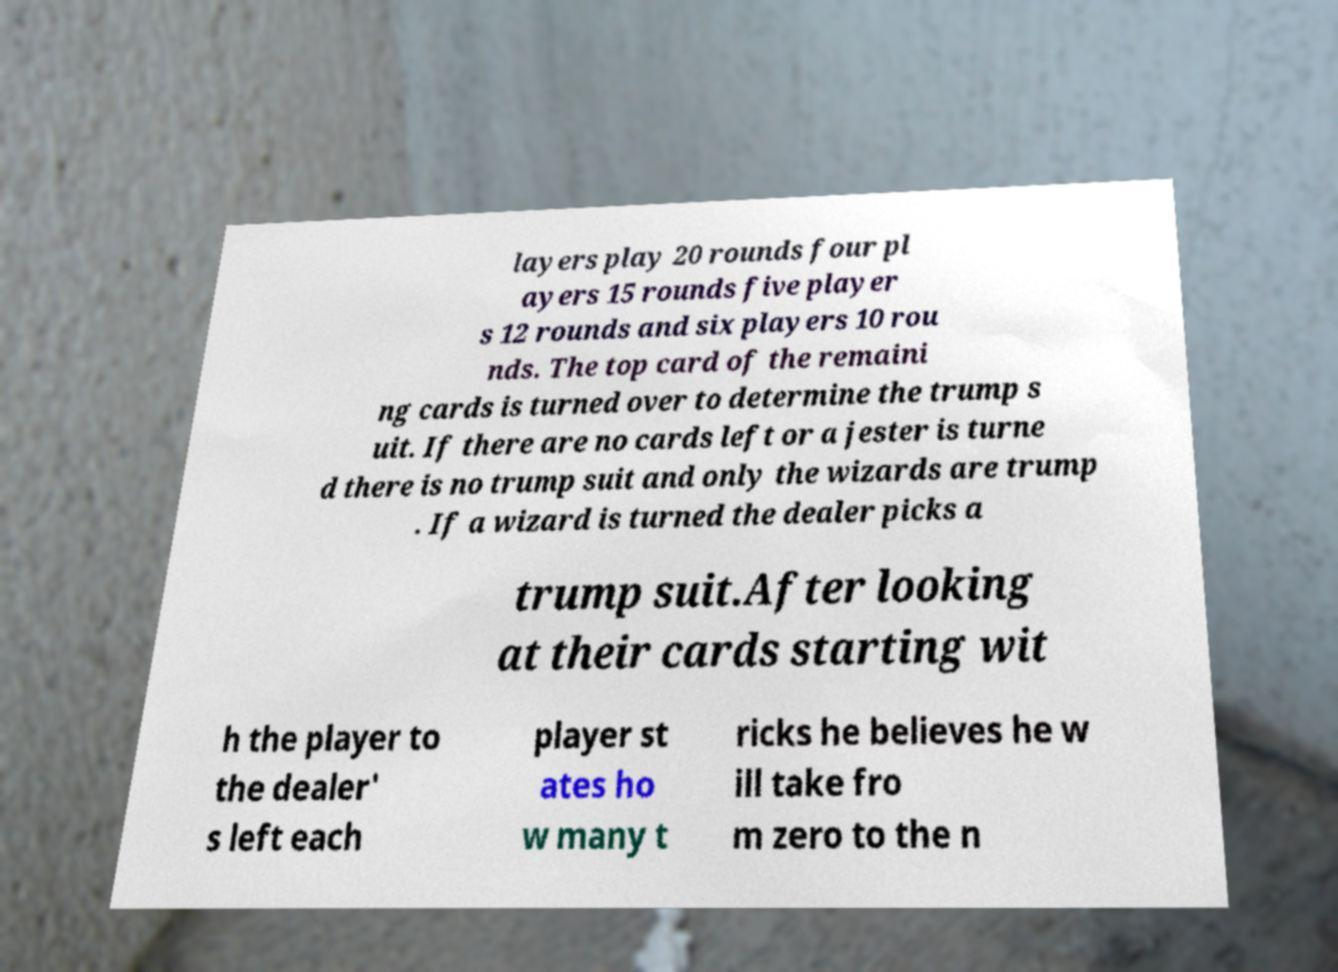Please identify and transcribe the text found in this image. layers play 20 rounds four pl ayers 15 rounds five player s 12 rounds and six players 10 rou nds. The top card of the remaini ng cards is turned over to determine the trump s uit. If there are no cards left or a jester is turne d there is no trump suit and only the wizards are trump . If a wizard is turned the dealer picks a trump suit.After looking at their cards starting wit h the player to the dealer' s left each player st ates ho w many t ricks he believes he w ill take fro m zero to the n 